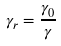<formula> <loc_0><loc_0><loc_500><loc_500>\gamma _ { r } = \frac { \gamma _ { 0 } } { \gamma }</formula> 